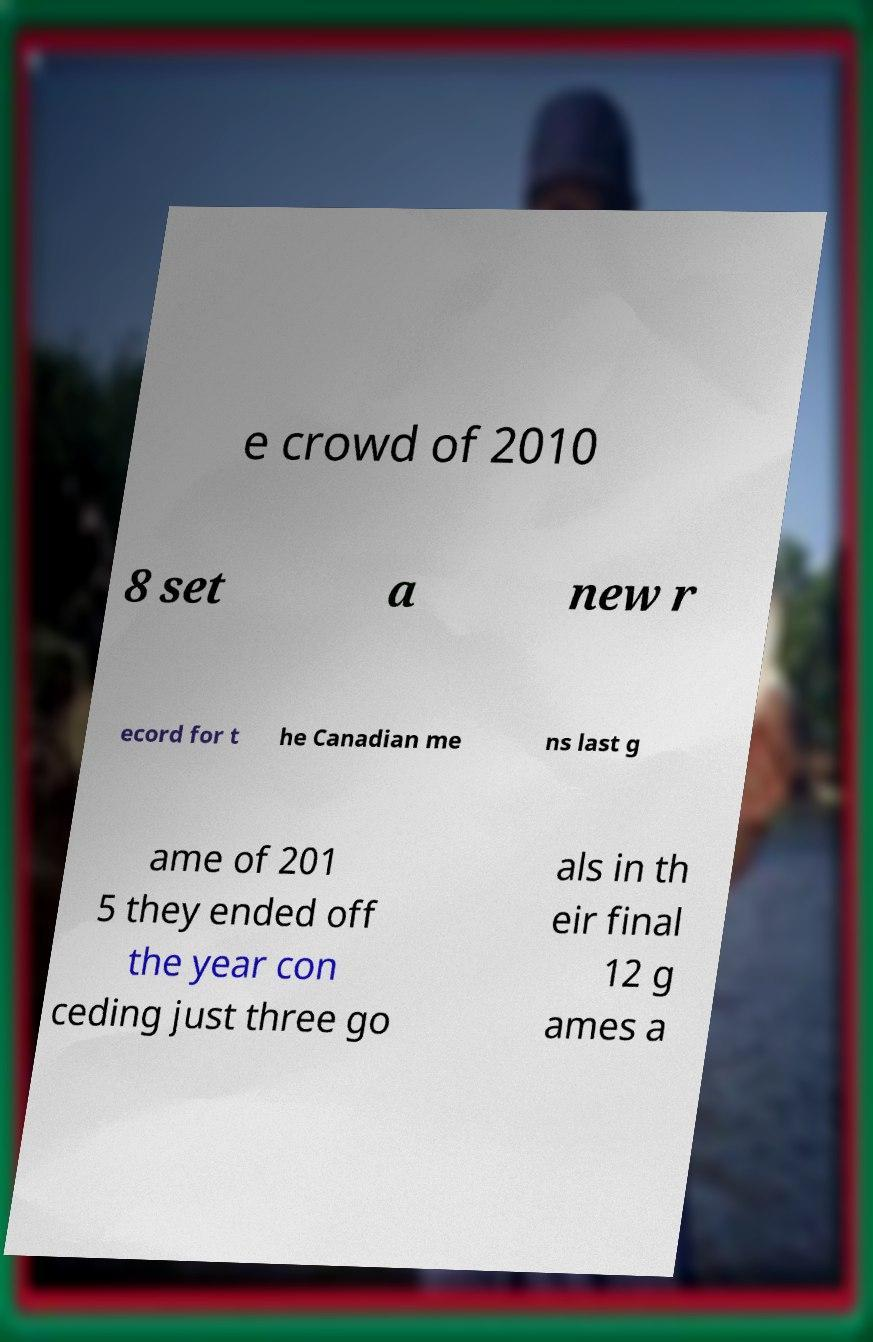Could you assist in decoding the text presented in this image and type it out clearly? e crowd of 2010 8 set a new r ecord for t he Canadian me ns last g ame of 201 5 they ended off the year con ceding just three go als in th eir final 12 g ames a 